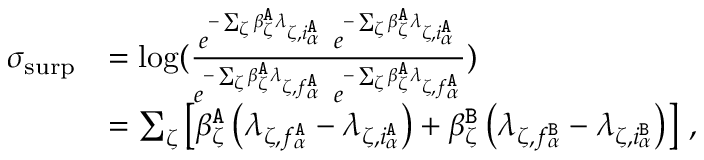Convert formula to latex. <formula><loc_0><loc_0><loc_500><loc_500>\begin{array} { r l } { \sigma _ { s u r p } } & { = \log ( \frac { e ^ { - \sum _ { \zeta } \beta _ { \zeta } ^ { \tt A } \lambda _ { \zeta , i _ { \alpha } ^ { \tt A } } } \ e ^ { - \sum _ { \zeta } \beta _ { \zeta } ^ { \tt A } \lambda _ { \zeta , i _ { \alpha } ^ { \tt A } } } } { e ^ { - \sum _ { \zeta } \beta _ { \zeta } ^ { \tt A } \lambda _ { \zeta , f _ { \alpha } ^ { \tt A } } } \ e ^ { - \sum _ { \zeta } \beta _ { \zeta } ^ { \tt A } \lambda _ { \zeta , f _ { \alpha } ^ { \tt A } } } } ) } \\ & { = \sum _ { \zeta } \left [ \beta _ { \zeta } ^ { \tt A } \left ( \lambda _ { \zeta , f _ { \alpha } ^ { \tt A } } - \lambda _ { \zeta , i _ { \alpha } ^ { \tt A } } \right ) + \beta _ { \zeta } ^ { \tt B } \left ( \lambda _ { \zeta , f _ { \alpha } ^ { \tt B } } - \lambda _ { \zeta , i _ { \alpha } ^ { \tt B } } \right ) \right ] \, , } \end{array}</formula> 